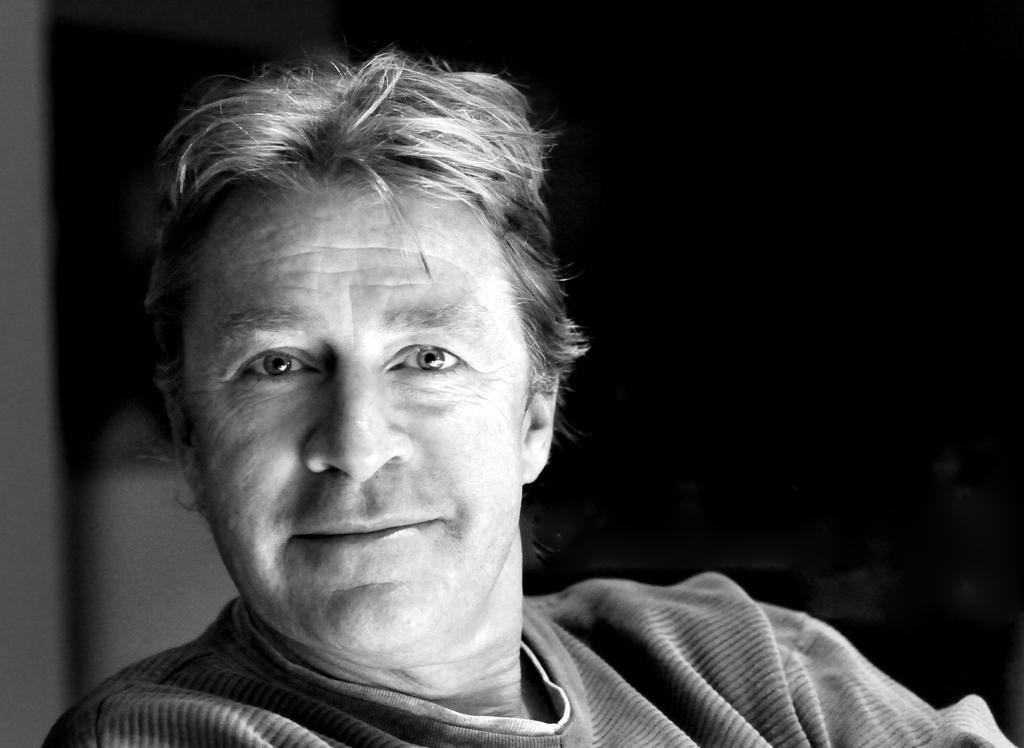Who is present in the image? There is a man in the image. What is the color scheme of the image? The image is black and white in color. What is the man's income in the image? There is no information about the man's income in the image. How many tables are visible in the image? There are no tables present in the image. 